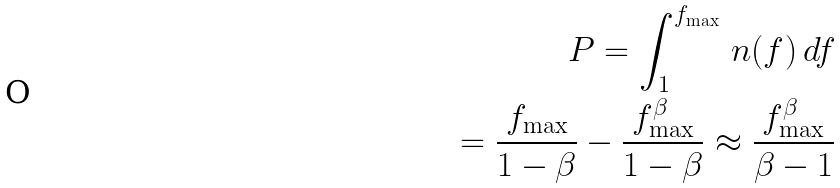<formula> <loc_0><loc_0><loc_500><loc_500>P = \int _ { 1 } ^ { f _ { \max } } \, n ( f ) \, d f \\ = \frac { f _ { \max } } { 1 - \beta } - \frac { f _ { \max } ^ { \beta } } { 1 - \beta } \approx \frac { f _ { \max } ^ { \beta } } { \beta - 1 }</formula> 